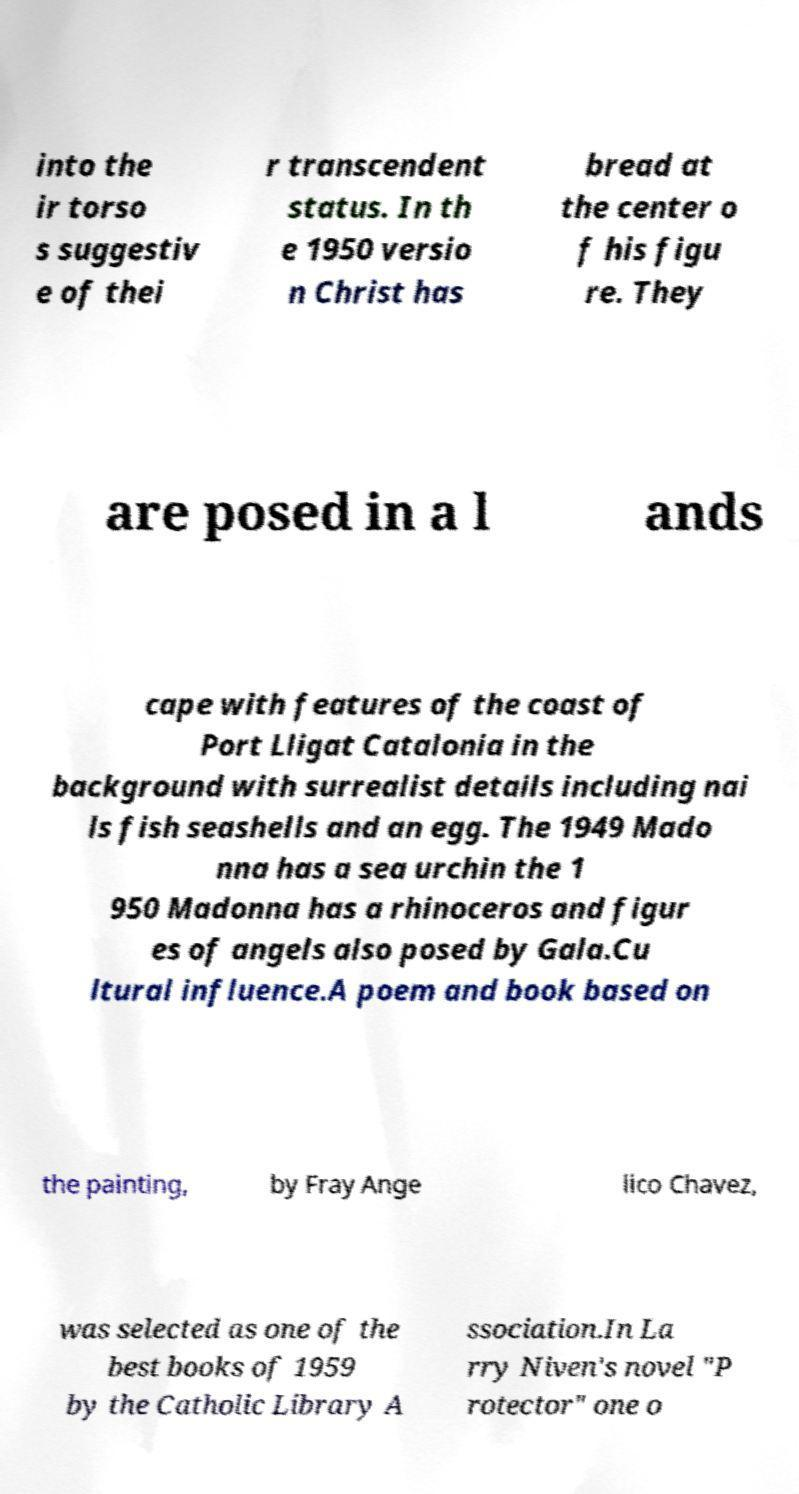Please identify and transcribe the text found in this image. into the ir torso s suggestiv e of thei r transcendent status. In th e 1950 versio n Christ has bread at the center o f his figu re. They are posed in a l ands cape with features of the coast of Port Lligat Catalonia in the background with surrealist details including nai ls fish seashells and an egg. The 1949 Mado nna has a sea urchin the 1 950 Madonna has a rhinoceros and figur es of angels also posed by Gala.Cu ltural influence.A poem and book based on the painting, by Fray Ange lico Chavez, was selected as one of the best books of 1959 by the Catholic Library A ssociation.In La rry Niven's novel "P rotector" one o 